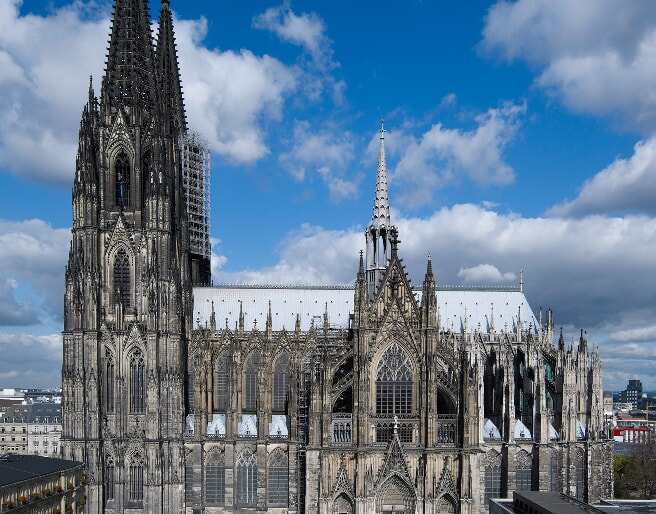Imagine if the Cologne Cathedral could speak, what stories do you think it would tell? If the Cologne Cathedral could speak, it would tell tales of centuries gone by, from its inception in the High Middle Ages to the present day. It would speak of the ambitious craftsmen and laborers who toiled over several centuries to realize its grandeur, under the shifting sands of politics, power, and faith. It would recount the solemn processions of kings and queens, the fervent prayers of pilgrims, and the evolution of worship practices through the Reformation. The cathedral might share stories of the city of Cologne itself through plagues, wars, and heights of prosperity. Narrowly escaping ruin during World War II, the cathedral would express gratitude for the resilience and dedication shown by the people of Cologne in restoring and preserving its sanctity. Its walls would echo with the voices of millions of visitors who have marveled at its beauty, the monks who whispered prayers in its cloisters, and the organ music that still resounds within its hallowed halls. Each stone, each carved figure, and each stained glass window has a rich story to impart, weaving a tapestry of human history and devotion. 